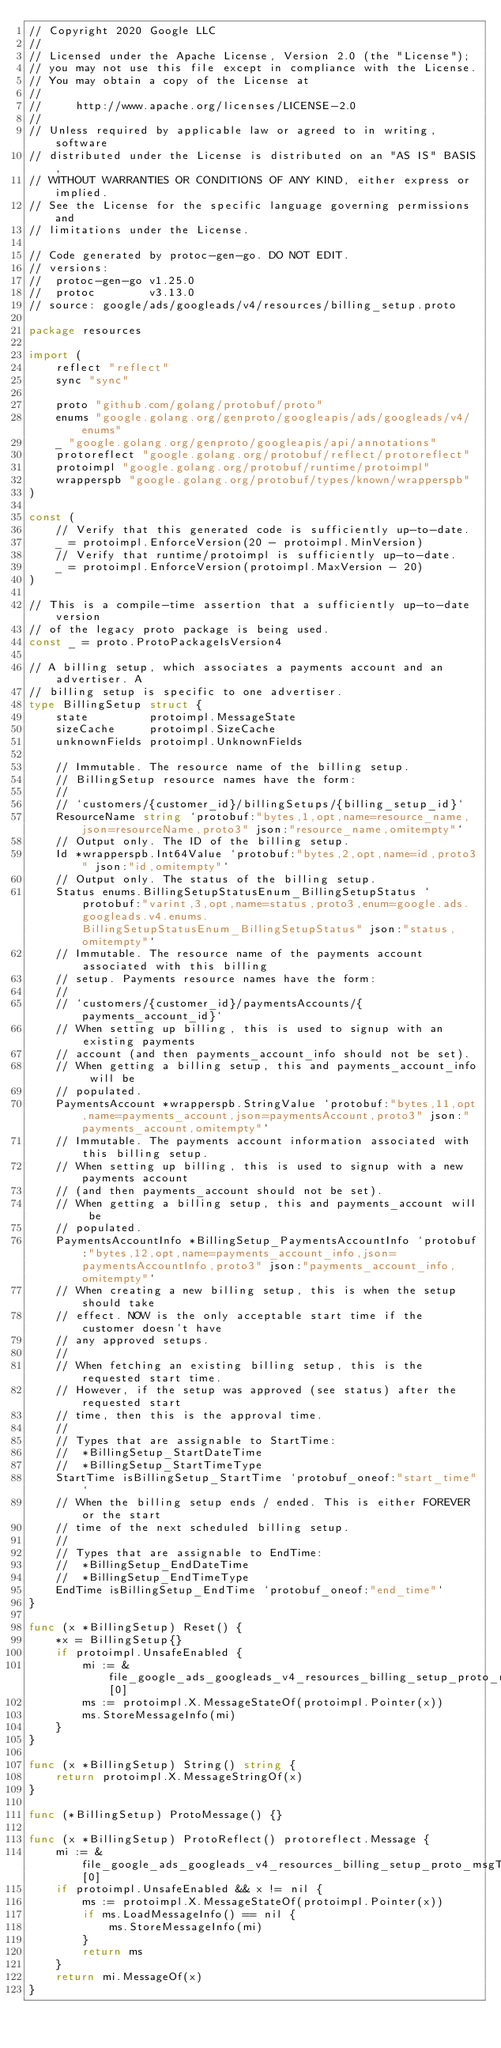Convert code to text. <code><loc_0><loc_0><loc_500><loc_500><_Go_>// Copyright 2020 Google LLC
//
// Licensed under the Apache License, Version 2.0 (the "License");
// you may not use this file except in compliance with the License.
// You may obtain a copy of the License at
//
//     http://www.apache.org/licenses/LICENSE-2.0
//
// Unless required by applicable law or agreed to in writing, software
// distributed under the License is distributed on an "AS IS" BASIS,
// WITHOUT WARRANTIES OR CONDITIONS OF ANY KIND, either express or implied.
// See the License for the specific language governing permissions and
// limitations under the License.

// Code generated by protoc-gen-go. DO NOT EDIT.
// versions:
// 	protoc-gen-go v1.25.0
// 	protoc        v3.13.0
// source: google/ads/googleads/v4/resources/billing_setup.proto

package resources

import (
	reflect "reflect"
	sync "sync"

	proto "github.com/golang/protobuf/proto"
	enums "google.golang.org/genproto/googleapis/ads/googleads/v4/enums"
	_ "google.golang.org/genproto/googleapis/api/annotations"
	protoreflect "google.golang.org/protobuf/reflect/protoreflect"
	protoimpl "google.golang.org/protobuf/runtime/protoimpl"
	wrapperspb "google.golang.org/protobuf/types/known/wrapperspb"
)

const (
	// Verify that this generated code is sufficiently up-to-date.
	_ = protoimpl.EnforceVersion(20 - protoimpl.MinVersion)
	// Verify that runtime/protoimpl is sufficiently up-to-date.
	_ = protoimpl.EnforceVersion(protoimpl.MaxVersion - 20)
)

// This is a compile-time assertion that a sufficiently up-to-date version
// of the legacy proto package is being used.
const _ = proto.ProtoPackageIsVersion4

// A billing setup, which associates a payments account and an advertiser. A
// billing setup is specific to one advertiser.
type BillingSetup struct {
	state         protoimpl.MessageState
	sizeCache     protoimpl.SizeCache
	unknownFields protoimpl.UnknownFields

	// Immutable. The resource name of the billing setup.
	// BillingSetup resource names have the form:
	//
	// `customers/{customer_id}/billingSetups/{billing_setup_id}`
	ResourceName string `protobuf:"bytes,1,opt,name=resource_name,json=resourceName,proto3" json:"resource_name,omitempty"`
	// Output only. The ID of the billing setup.
	Id *wrapperspb.Int64Value `protobuf:"bytes,2,opt,name=id,proto3" json:"id,omitempty"`
	// Output only. The status of the billing setup.
	Status enums.BillingSetupStatusEnum_BillingSetupStatus `protobuf:"varint,3,opt,name=status,proto3,enum=google.ads.googleads.v4.enums.BillingSetupStatusEnum_BillingSetupStatus" json:"status,omitempty"`
	// Immutable. The resource name of the payments account associated with this billing
	// setup. Payments resource names have the form:
	//
	// `customers/{customer_id}/paymentsAccounts/{payments_account_id}`
	// When setting up billing, this is used to signup with an existing payments
	// account (and then payments_account_info should not be set).
	// When getting a billing setup, this and payments_account_info will be
	// populated.
	PaymentsAccount *wrapperspb.StringValue `protobuf:"bytes,11,opt,name=payments_account,json=paymentsAccount,proto3" json:"payments_account,omitempty"`
	// Immutable. The payments account information associated with this billing setup.
	// When setting up billing, this is used to signup with a new payments account
	// (and then payments_account should not be set).
	// When getting a billing setup, this and payments_account will be
	// populated.
	PaymentsAccountInfo *BillingSetup_PaymentsAccountInfo `protobuf:"bytes,12,opt,name=payments_account_info,json=paymentsAccountInfo,proto3" json:"payments_account_info,omitempty"`
	// When creating a new billing setup, this is when the setup should take
	// effect. NOW is the only acceptable start time if the customer doesn't have
	// any approved setups.
	//
	// When fetching an existing billing setup, this is the requested start time.
	// However, if the setup was approved (see status) after the requested start
	// time, then this is the approval time.
	//
	// Types that are assignable to StartTime:
	//	*BillingSetup_StartDateTime
	//	*BillingSetup_StartTimeType
	StartTime isBillingSetup_StartTime `protobuf_oneof:"start_time"`
	// When the billing setup ends / ended. This is either FOREVER or the start
	// time of the next scheduled billing setup.
	//
	// Types that are assignable to EndTime:
	//	*BillingSetup_EndDateTime
	//	*BillingSetup_EndTimeType
	EndTime isBillingSetup_EndTime `protobuf_oneof:"end_time"`
}

func (x *BillingSetup) Reset() {
	*x = BillingSetup{}
	if protoimpl.UnsafeEnabled {
		mi := &file_google_ads_googleads_v4_resources_billing_setup_proto_msgTypes[0]
		ms := protoimpl.X.MessageStateOf(protoimpl.Pointer(x))
		ms.StoreMessageInfo(mi)
	}
}

func (x *BillingSetup) String() string {
	return protoimpl.X.MessageStringOf(x)
}

func (*BillingSetup) ProtoMessage() {}

func (x *BillingSetup) ProtoReflect() protoreflect.Message {
	mi := &file_google_ads_googleads_v4_resources_billing_setup_proto_msgTypes[0]
	if protoimpl.UnsafeEnabled && x != nil {
		ms := protoimpl.X.MessageStateOf(protoimpl.Pointer(x))
		if ms.LoadMessageInfo() == nil {
			ms.StoreMessageInfo(mi)
		}
		return ms
	}
	return mi.MessageOf(x)
}
</code> 